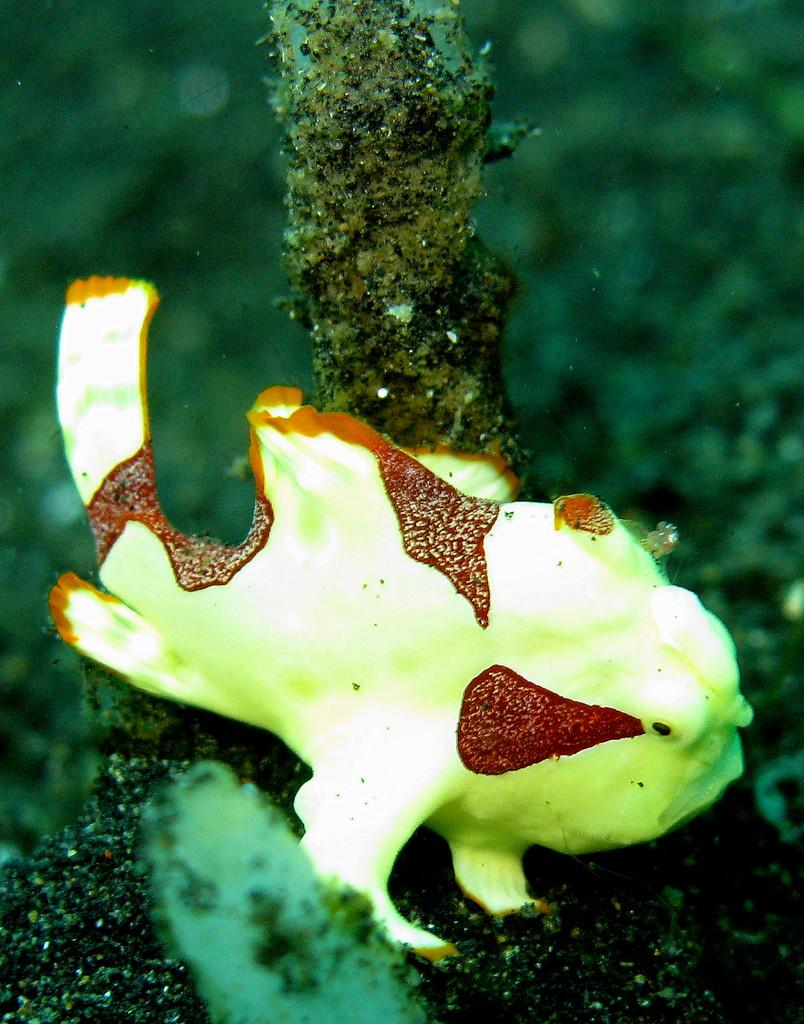What type of environment is shown in the image? The image depicts an underwater environment. What can be seen among the underwater elements in the image? There are branches visible in the image. Are there any animals present in the underwater environment? Yes, there is a sea slug in the image. What color is the scarf worn by the sea slug in the image? There is no scarf present in the image, as sea slugs do not wear clothing. How many sparks can be seen around the sea slug in the image? There are no sparks present in the image, as it depicts an underwater environment. 